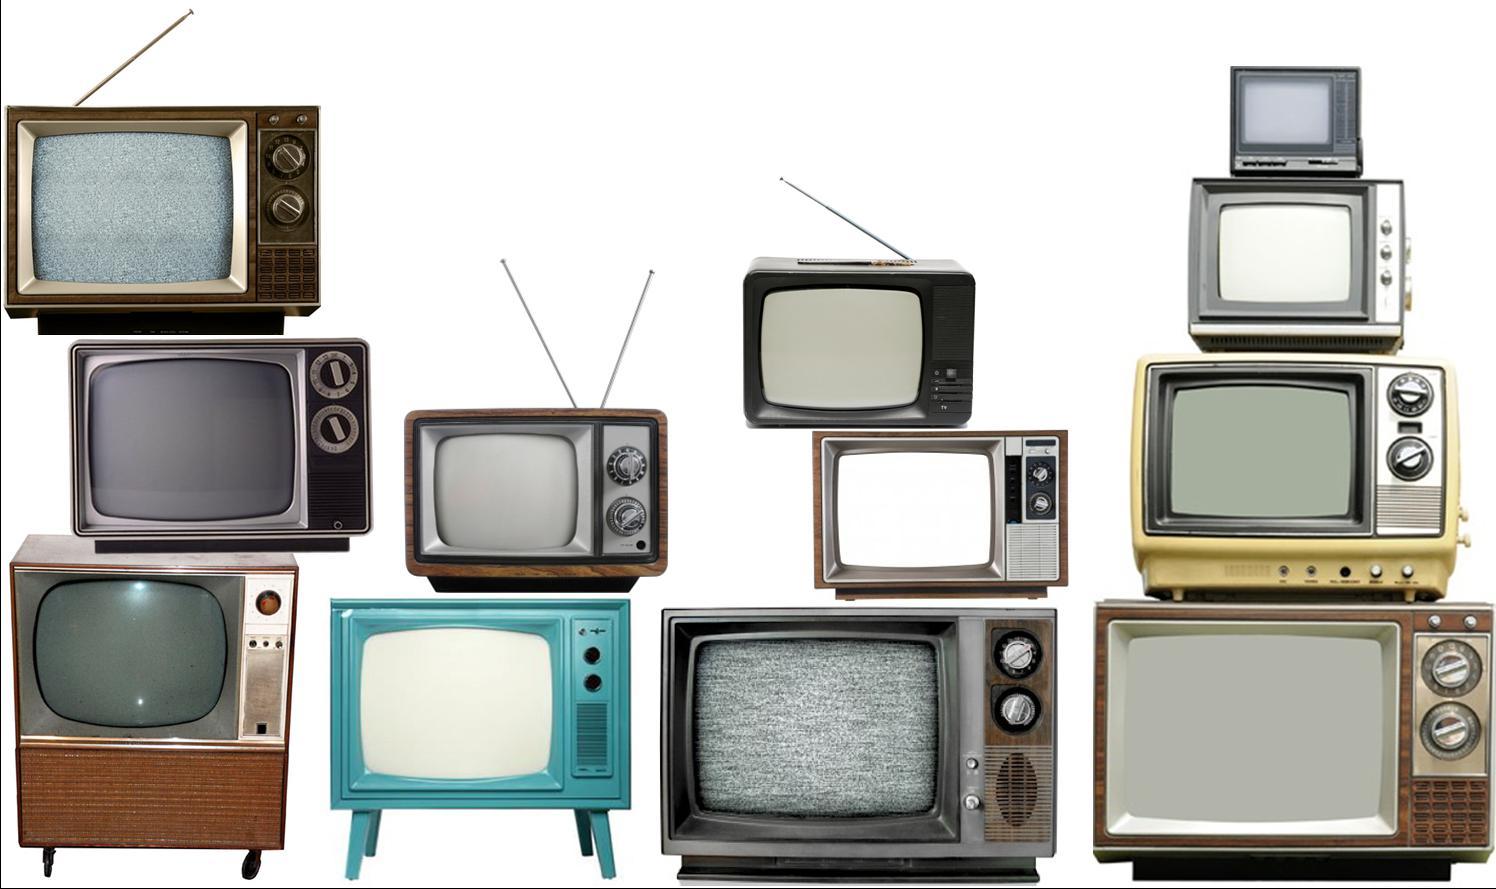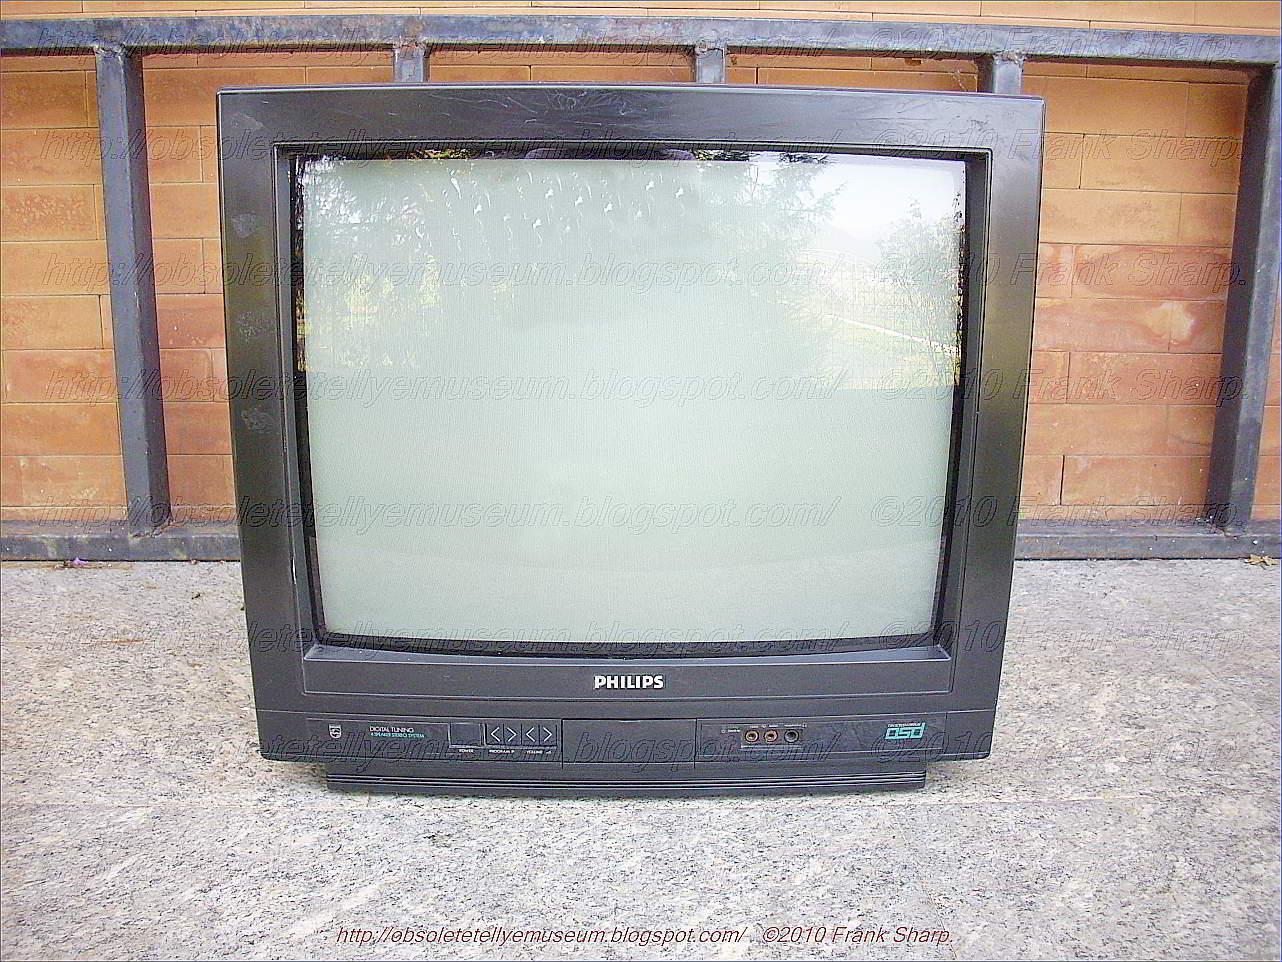The first image is the image on the left, the second image is the image on the right. For the images displayed, is the sentence "There are no more than 5 and no less than 2 televisions in a single image." factually correct? Answer yes or no. No. The first image is the image on the left, the second image is the image on the right. Analyze the images presented: Is the assertion "There are no more than 5 televisions in the right image." valid? Answer yes or no. Yes. 